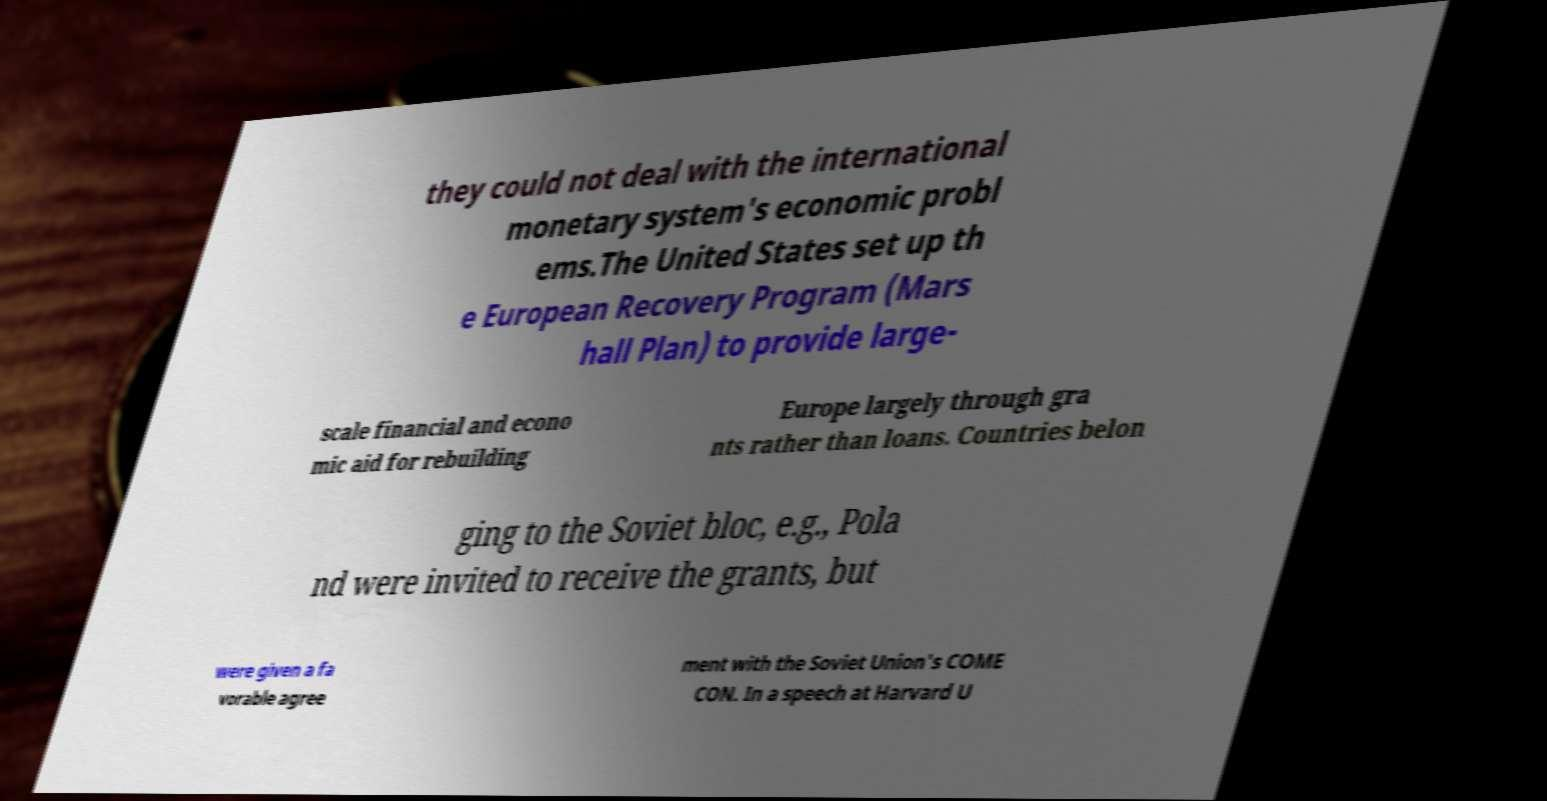Could you extract and type out the text from this image? they could not deal with the international monetary system's economic probl ems.The United States set up th e European Recovery Program (Mars hall Plan) to provide large- scale financial and econo mic aid for rebuilding Europe largely through gra nts rather than loans. Countries belon ging to the Soviet bloc, e.g., Pola nd were invited to receive the grants, but were given a fa vorable agree ment with the Soviet Union's COME CON. In a speech at Harvard U 